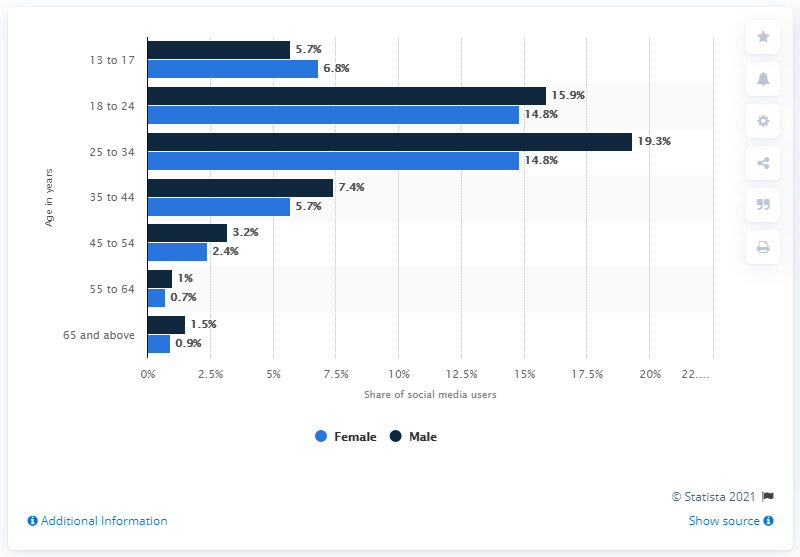Draw attention to some important aspects in this diagram. According to a recent survey, 19.3% of males between the ages of 25 and 34 use social media. The difference between the males aged 35 to 44 and females aged 35 to 44 is 1.7%. 